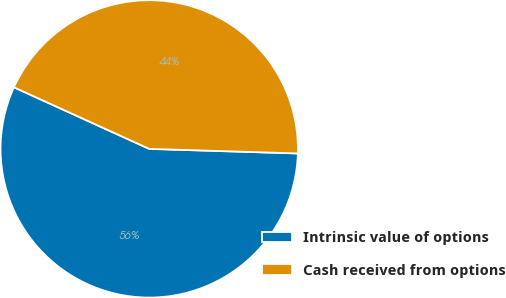Convert chart to OTSL. <chart><loc_0><loc_0><loc_500><loc_500><pie_chart><fcel>Intrinsic value of options<fcel>Cash received from options<nl><fcel>56.31%<fcel>43.69%<nl></chart> 